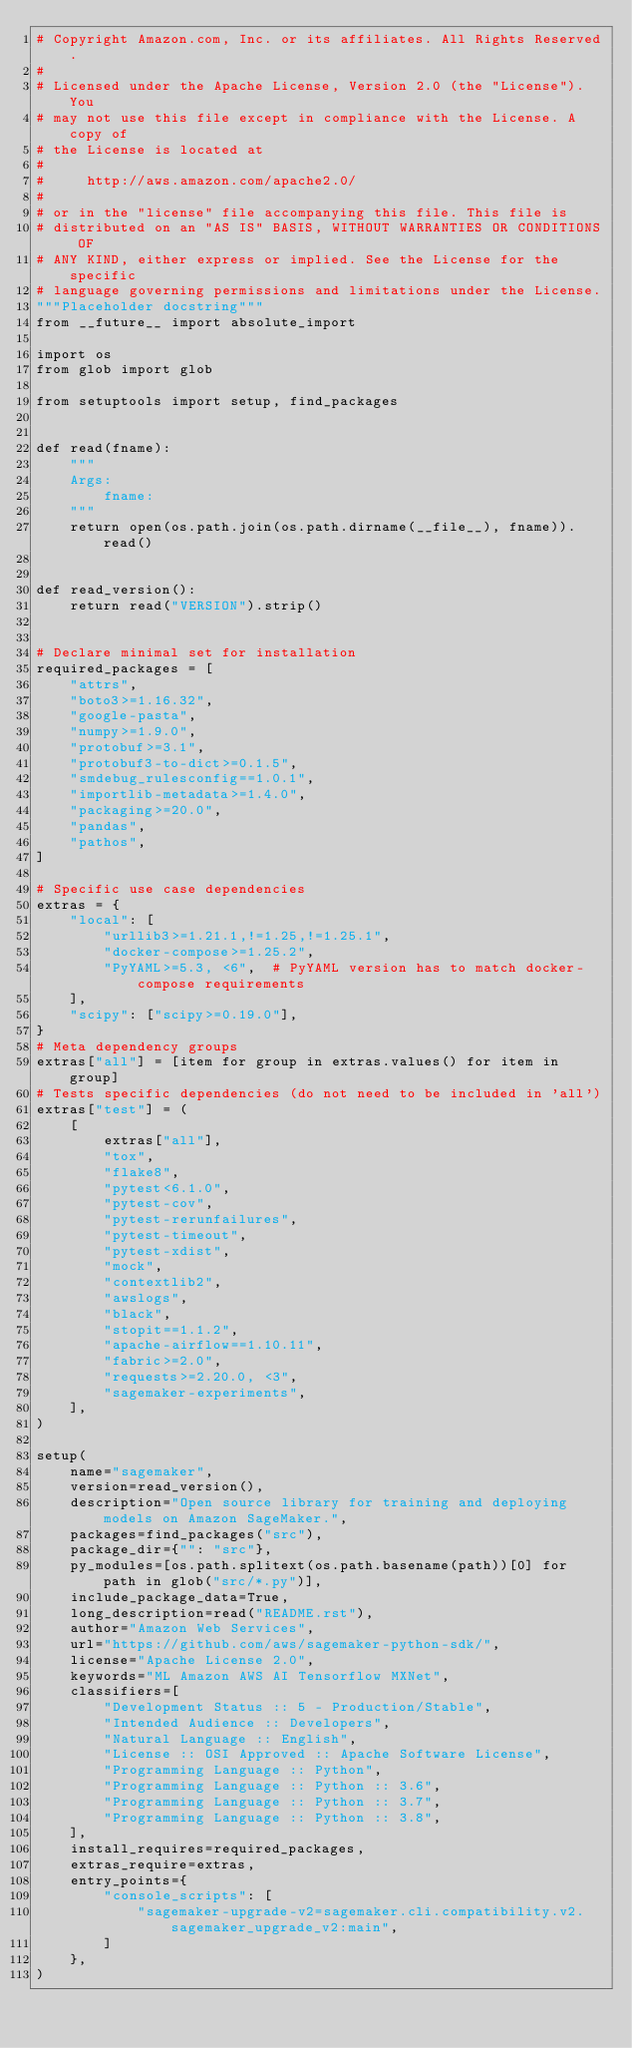Convert code to text. <code><loc_0><loc_0><loc_500><loc_500><_Python_># Copyright Amazon.com, Inc. or its affiliates. All Rights Reserved.
#
# Licensed under the Apache License, Version 2.0 (the "License"). You
# may not use this file except in compliance with the License. A copy of
# the License is located at
#
#     http://aws.amazon.com/apache2.0/
#
# or in the "license" file accompanying this file. This file is
# distributed on an "AS IS" BASIS, WITHOUT WARRANTIES OR CONDITIONS OF
# ANY KIND, either express or implied. See the License for the specific
# language governing permissions and limitations under the License.
"""Placeholder docstring"""
from __future__ import absolute_import

import os
from glob import glob

from setuptools import setup, find_packages


def read(fname):
    """
    Args:
        fname:
    """
    return open(os.path.join(os.path.dirname(__file__), fname)).read()


def read_version():
    return read("VERSION").strip()


# Declare minimal set for installation
required_packages = [
    "attrs",
    "boto3>=1.16.32",
    "google-pasta",
    "numpy>=1.9.0",
    "protobuf>=3.1",
    "protobuf3-to-dict>=0.1.5",
    "smdebug_rulesconfig==1.0.1",
    "importlib-metadata>=1.4.0",
    "packaging>=20.0",
    "pandas",
    "pathos",
]

# Specific use case dependencies
extras = {
    "local": [
        "urllib3>=1.21.1,!=1.25,!=1.25.1",
        "docker-compose>=1.25.2",
        "PyYAML>=5.3, <6",  # PyYAML version has to match docker-compose requirements
    ],
    "scipy": ["scipy>=0.19.0"],
}
# Meta dependency groups
extras["all"] = [item for group in extras.values() for item in group]
# Tests specific dependencies (do not need to be included in 'all')
extras["test"] = (
    [
        extras["all"],
        "tox",
        "flake8",
        "pytest<6.1.0",
        "pytest-cov",
        "pytest-rerunfailures",
        "pytest-timeout",
        "pytest-xdist",
        "mock",
        "contextlib2",
        "awslogs",
        "black",
        "stopit==1.1.2",
        "apache-airflow==1.10.11",
        "fabric>=2.0",
        "requests>=2.20.0, <3",
        "sagemaker-experiments",
    ],
)

setup(
    name="sagemaker",
    version=read_version(),
    description="Open source library for training and deploying models on Amazon SageMaker.",
    packages=find_packages("src"),
    package_dir={"": "src"},
    py_modules=[os.path.splitext(os.path.basename(path))[0] for path in glob("src/*.py")],
    include_package_data=True,
    long_description=read("README.rst"),
    author="Amazon Web Services",
    url="https://github.com/aws/sagemaker-python-sdk/",
    license="Apache License 2.0",
    keywords="ML Amazon AWS AI Tensorflow MXNet",
    classifiers=[
        "Development Status :: 5 - Production/Stable",
        "Intended Audience :: Developers",
        "Natural Language :: English",
        "License :: OSI Approved :: Apache Software License",
        "Programming Language :: Python",
        "Programming Language :: Python :: 3.6",
        "Programming Language :: Python :: 3.7",
        "Programming Language :: Python :: 3.8",
    ],
    install_requires=required_packages,
    extras_require=extras,
    entry_points={
        "console_scripts": [
            "sagemaker-upgrade-v2=sagemaker.cli.compatibility.v2.sagemaker_upgrade_v2:main",
        ]
    },
)
</code> 